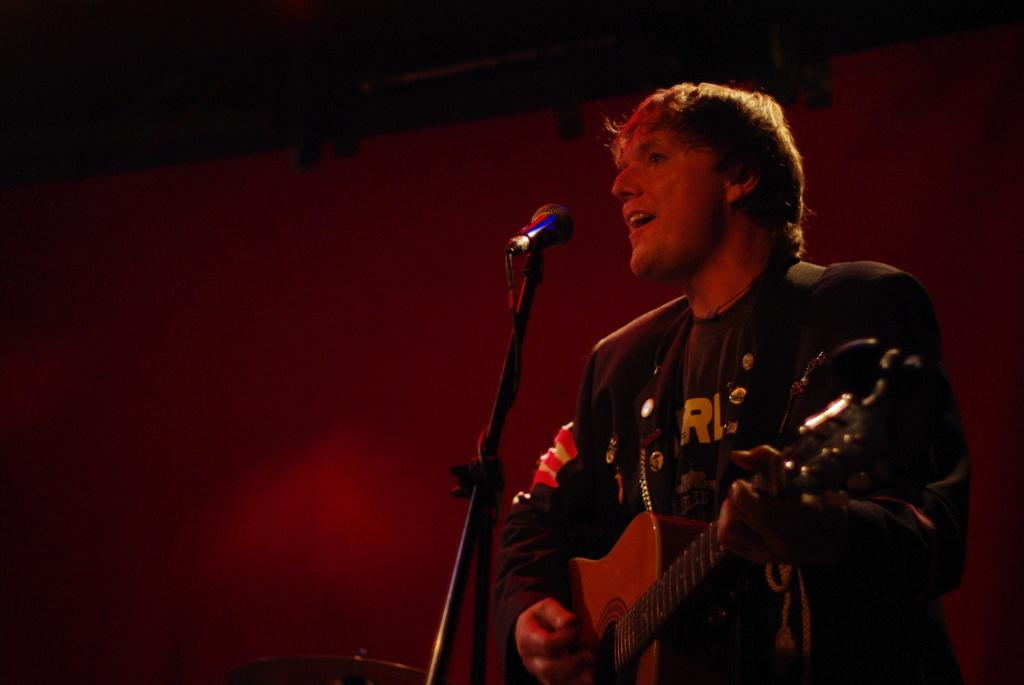What is the person in the image doing? The person is playing. What object is the person using while playing? The information provided does not specify any object being used. Can you describe the location where the person is playing? The location is not mentioned in the given facts. Which direction is the person facing in the image? The direction the person is facing is not mentioned in the given facts. What is the cent of the image? The term "cent" is not relevant to the image, as it refers to a unit of measurement or currency, not a visual element. 